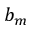<formula> <loc_0><loc_0><loc_500><loc_500>b _ { m }</formula> 